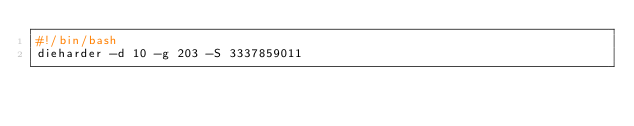Convert code to text. <code><loc_0><loc_0><loc_500><loc_500><_Bash_>#!/bin/bash
dieharder -d 10 -g 203 -S 3337859011
</code> 